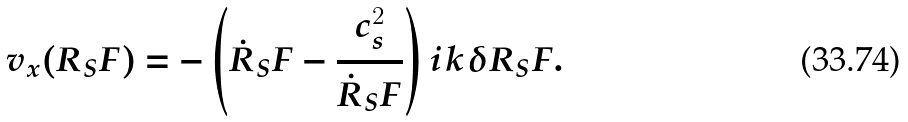<formula> <loc_0><loc_0><loc_500><loc_500>v _ { x } ( R _ { S } F ) = - \left ( \dot { R } _ { S } F - \frac { c _ { s } ^ { 2 } } { \dot { R } _ { S } F } \right ) i k \delta R _ { S } F .</formula> 